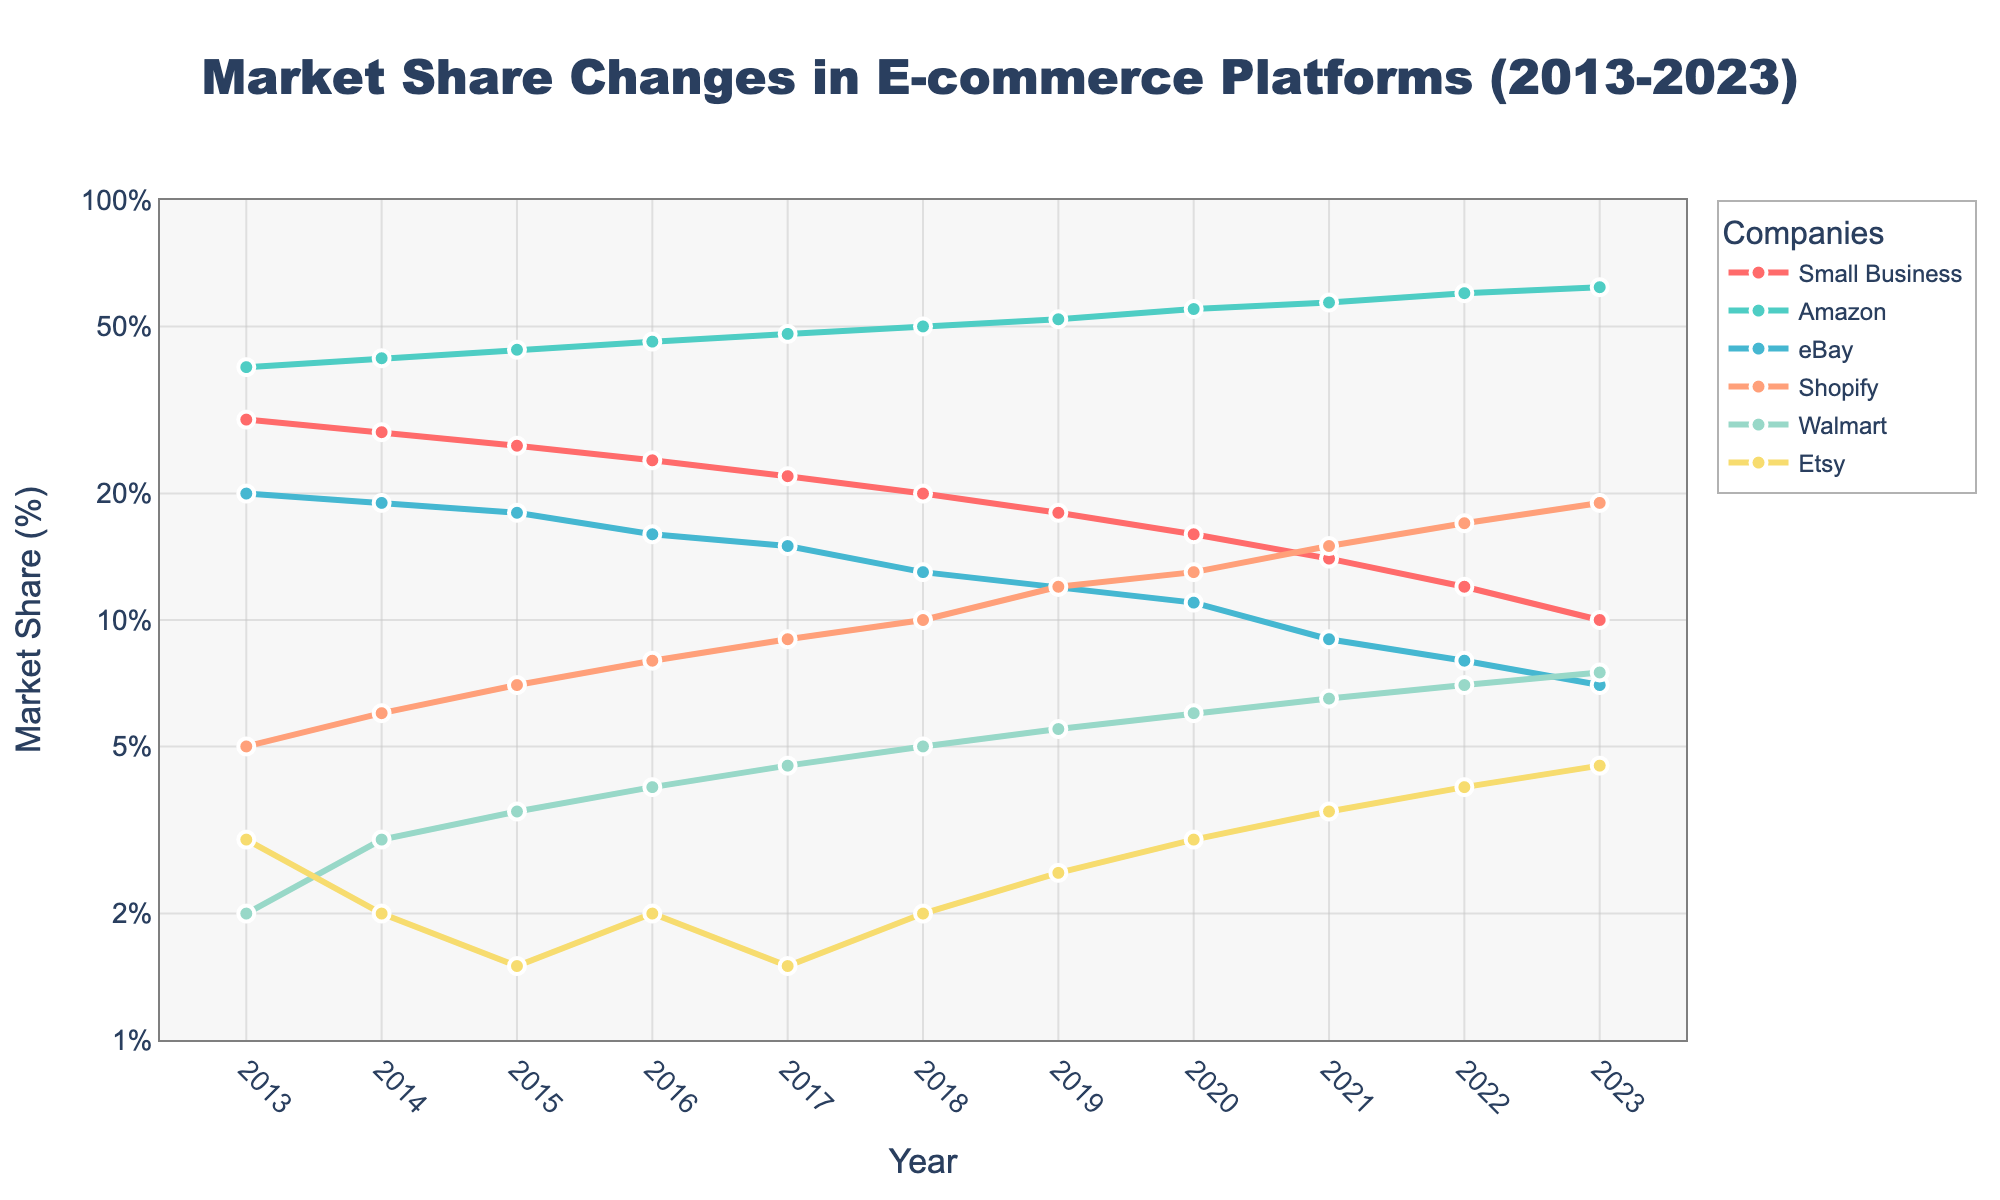What's the title of the figure? The title of the figure is usually found at the top. In this case, it is "Market Share Changes in E-commerce Platforms (2013-2023)".
Answer: Market Share Changes in E-commerce Platforms (2013-2023) What years are represented on the x-axis? The x-axis typically shows the range of years. Here, it spans from 2013 to 2023.
Answer: 2013 to 2023 Between 2013 and 2023, how many data points are there for each company? Each company has one data point per year from 2013 to 2023, making it 11 data points each.
Answer: 11 Which company had the highest market share in 2023? By examining the y-axis values for the year 2023, Amazon’s market share is the highest at 62%.
Answer: Amazon By how much did the market share of Small Businesses drop from 2013 to 2023? Subtracting the Small Business market share value in 2023 from that in 2013 (30% - 10%) gives the drop.
Answer: 20% What trend can be observed in Shopify's market share from 2013 to 2023? Observing the line for Shopify from 2013 to 2023, there is a clear upward trend in its market share.
Answer: Upward Which two companies had decreasing market shares over the 10 years? Evaluating the trends for all companies, Small Businesses and eBay had lines showing decreasing trends.
Answer: Small Businesses, eBay Is Etsy's market share always higher than Walmart's market share throughout the years? Comparing the market share lines of Etsy and Walmart from 2013 to 2023, it’s clear that Etsy’s is consistently lower.
Answer: No What was the approximate market share of Shopify in 2018? Checking the market share value for Shopify in the year 2018 on the y-axis, it is approximately 10%.
Answer: 10% Which company showed the most significant market share increase from 2013 to 2023? By comparing the initial and final market shares, Amazon showed the most significant increase (40% to 62%).
Answer: Amazon 